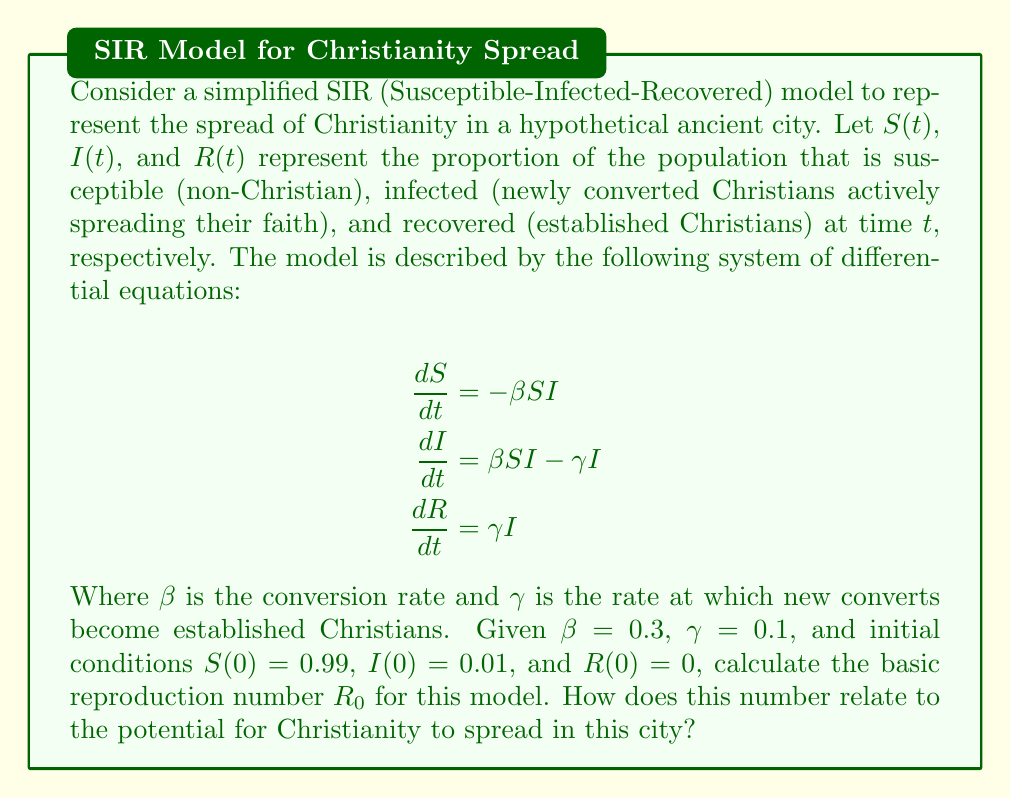Help me with this question. To solve this problem, we need to understand the concept of the basic reproduction number $R_0$ in the context of epidemic models and how it applies to the spread of Christianity.

1) The basic reproduction number $R_0$ is defined as the average number of secondary cases produced by a single infected individual in a completely susceptible population.

2) In the SIR model, $R_0$ is calculated using the formula:

   $$R_0 = \frac{\beta}{\gamma}$$

   Where $\beta$ is the infection (or in this case, conversion) rate, and $\gamma$ is the recovery (or establishment) rate.

3) Given the values:
   $\beta = 0.3$ (conversion rate)
   $\gamma = 0.1$ (establishment rate)

4) We can now calculate $R_0$:

   $$R_0 = \frac{0.3}{0.1} = 3$$

5) Interpretation of $R_0$ in this context:
   - If $R_0 > 1$, the spread of Christianity is likely to increase and potentially lead to a significant portion of the population converting.
   - If $R_0 = 1$, the spread of Christianity is likely to remain stable.
   - If $R_0 < 1$, the spread of Christianity is likely to decline and eventually stop.

6) In this case, $R_0 = 3$, which means that on average, each new Christian convert is expected to convert 3 more people before becoming an established Christian.

7) This value of $R_0$ suggests that Christianity has the potential to spread rapidly in this hypothetical ancient city, as each new convert is likely to create more than one new convert before becoming established.
Answer: The basic reproduction number $R_0 = 3$. This indicates that Christianity has a high potential for spread in this city, as each new convert is expected to convert 3 more people on average before becoming an established Christian. 